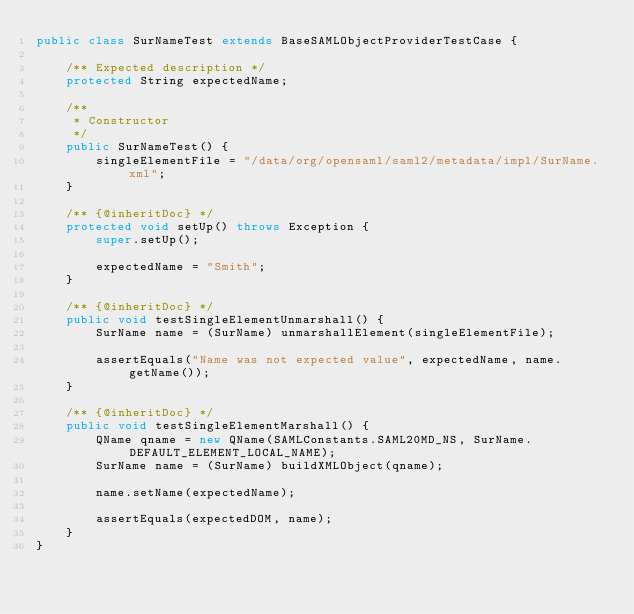Convert code to text. <code><loc_0><loc_0><loc_500><loc_500><_Java_>public class SurNameTest extends BaseSAMLObjectProviderTestCase {
    
    /** Expected description */
    protected String expectedName;
    
    /**
     * Constructor
     */
    public SurNameTest() {
        singleElementFile = "/data/org/opensaml/saml2/metadata/impl/SurName.xml";
    }
    
    /** {@inheritDoc} */
    protected void setUp() throws Exception {
        super.setUp();
        
        expectedName = "Smith";
    }

    /** {@inheritDoc} */
    public void testSingleElementUnmarshall() {
        SurName name = (SurName) unmarshallElement(singleElementFile);
        
        assertEquals("Name was not expected value", expectedName, name.getName());
    }

    /** {@inheritDoc} */
    public void testSingleElementMarshall() {
        QName qname = new QName(SAMLConstants.SAML20MD_NS, SurName.DEFAULT_ELEMENT_LOCAL_NAME);
        SurName name = (SurName) buildXMLObject(qname);
        
        name.setName(expectedName);

        assertEquals(expectedDOM, name);
    }
}</code> 